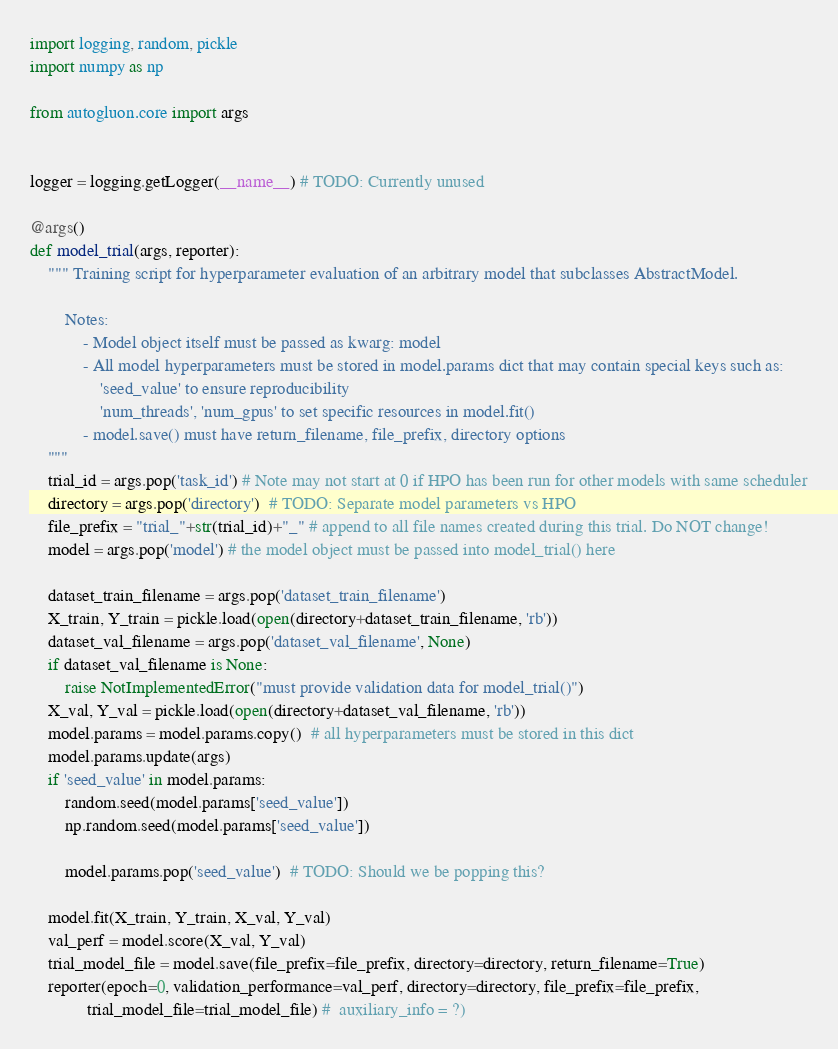<code> <loc_0><loc_0><loc_500><loc_500><_Python_>import logging, random, pickle
import numpy as np

from autogluon.core import args


logger = logging.getLogger(__name__) # TODO: Currently unused

@args()
def model_trial(args, reporter):
    """ Training script for hyperparameter evaluation of an arbitrary model that subclasses AbstractModel.
        
        Notes:
            - Model object itself must be passed as kwarg: model
            - All model hyperparameters must be stored in model.params dict that may contain special keys such as:
                'seed_value' to ensure reproducibility
                'num_threads', 'num_gpus' to set specific resources in model.fit()
            - model.save() must have return_filename, file_prefix, directory options
    """
    trial_id = args.pop('task_id') # Note may not start at 0 if HPO has been run for other models with same scheduler
    directory = args.pop('directory')  # TODO: Separate model parameters vs HPO
    file_prefix = "trial_"+str(trial_id)+"_" # append to all file names created during this trial. Do NOT change!
    model = args.pop('model') # the model object must be passed into model_trial() here

    dataset_train_filename = args.pop('dataset_train_filename')
    X_train, Y_train = pickle.load(open(directory+dataset_train_filename, 'rb'))
    dataset_val_filename = args.pop('dataset_val_filename', None)
    if dataset_val_filename is None:
        raise NotImplementedError("must provide validation data for model_trial()")
    X_val, Y_val = pickle.load(open(directory+dataset_val_filename, 'rb'))
    model.params = model.params.copy()  # all hyperparameters must be stored in this dict
    model.params.update(args)
    if 'seed_value' in model.params:
        random.seed(model.params['seed_value'])
        np.random.seed(model.params['seed_value'])

        model.params.pop('seed_value')  # TODO: Should we be popping this?

    model.fit(X_train, Y_train, X_val, Y_val)
    val_perf = model.score(X_val, Y_val)
    trial_model_file = model.save(file_prefix=file_prefix, directory=directory, return_filename=True)
    reporter(epoch=0, validation_performance=val_perf, directory=directory, file_prefix=file_prefix, 
             trial_model_file=trial_model_file) #  auxiliary_info = ?)

</code> 